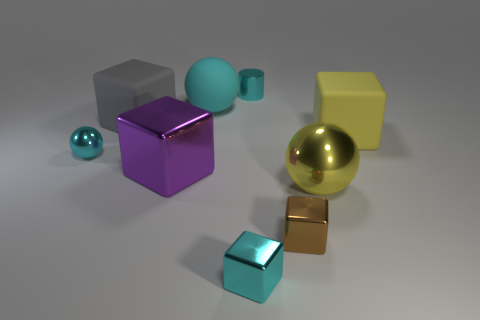Subtract all cyan shiny blocks. How many blocks are left? 4 Add 1 tiny metal cylinders. How many objects exist? 10 Subtract all cylinders. How many objects are left? 8 Subtract 1 balls. How many balls are left? 2 Subtract all cyan blocks. How many blocks are left? 4 Subtract all purple balls. How many gray cubes are left? 1 Subtract 1 cyan cylinders. How many objects are left? 8 Subtract all red blocks. Subtract all cyan cylinders. How many blocks are left? 5 Subtract all tiny brown objects. Subtract all shiny objects. How many objects are left? 2 Add 3 brown shiny cubes. How many brown shiny cubes are left? 4 